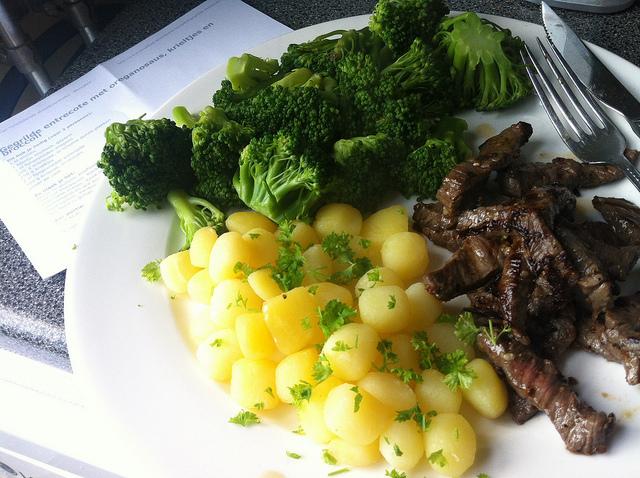Is there a spoon on the plate?
Give a very brief answer. No. What is the meat?
Keep it brief. Steak. Where are the corn?
Short answer required. On plate. What are the green vegetables called?
Quick response, please. Broccoli. Where is the corn?
Answer briefly. Plate. 